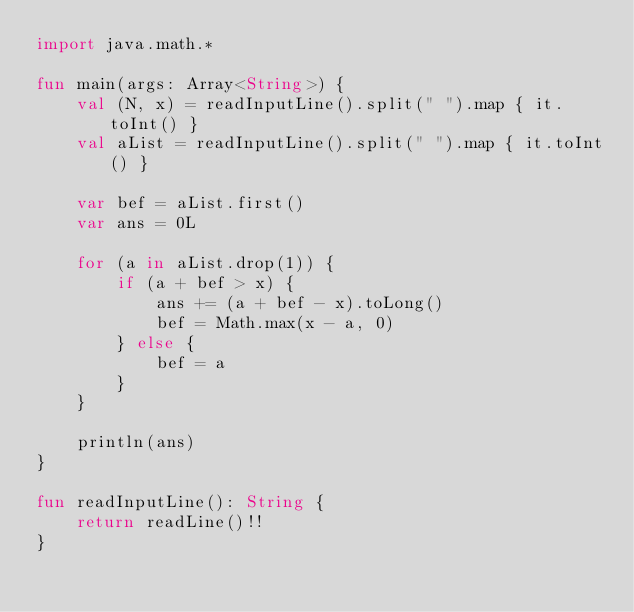Convert code to text. <code><loc_0><loc_0><loc_500><loc_500><_Kotlin_>import java.math.*

fun main(args: Array<String>) {
    val (N, x) = readInputLine().split(" ").map { it.toInt() }
    val aList = readInputLine().split(" ").map { it.toInt() }
    
    var bef = aList.first()
    var ans = 0L
    
    for (a in aList.drop(1)) {
        if (a + bef > x) {
            ans += (a + bef - x).toLong()
            bef = Math.max(x - a, 0)
        } else {
            bef = a
        }
    }

    println(ans)
}

fun readInputLine(): String {
    return readLine()!!
}

</code> 